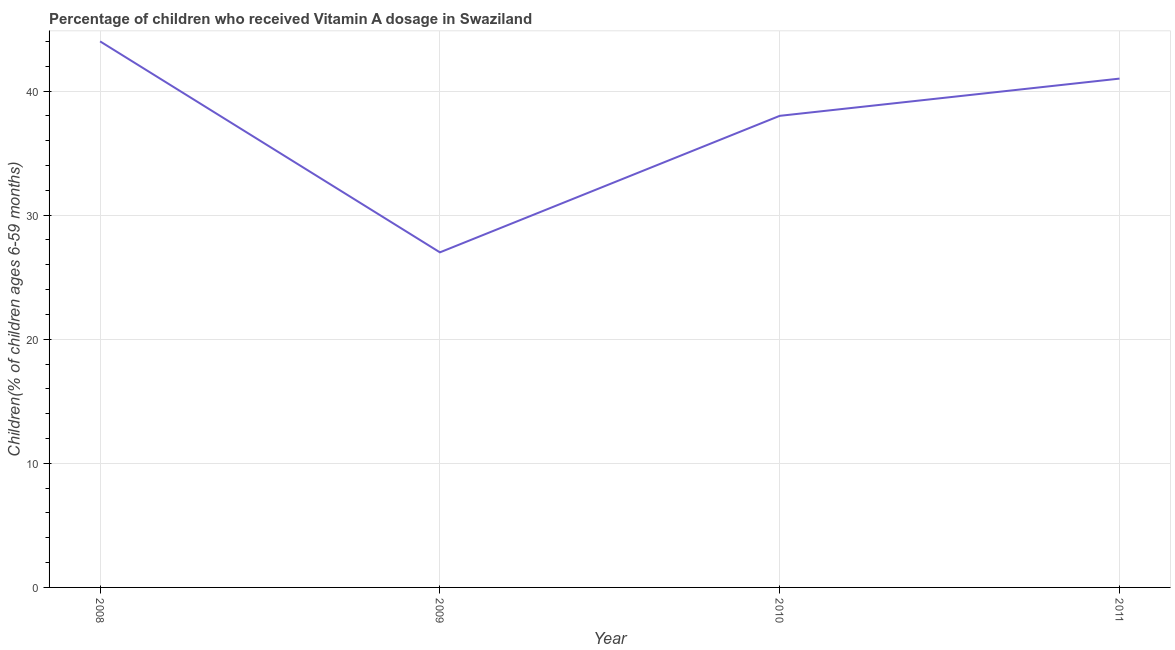What is the vitamin a supplementation coverage rate in 2010?
Offer a terse response. 38. Across all years, what is the maximum vitamin a supplementation coverage rate?
Make the answer very short. 44. Across all years, what is the minimum vitamin a supplementation coverage rate?
Offer a terse response. 27. In which year was the vitamin a supplementation coverage rate maximum?
Ensure brevity in your answer.  2008. What is the sum of the vitamin a supplementation coverage rate?
Make the answer very short. 150. What is the difference between the vitamin a supplementation coverage rate in 2010 and 2011?
Provide a succinct answer. -3. What is the average vitamin a supplementation coverage rate per year?
Your answer should be compact. 37.5. What is the median vitamin a supplementation coverage rate?
Give a very brief answer. 39.5. In how many years, is the vitamin a supplementation coverage rate greater than 40 %?
Give a very brief answer. 2. What is the ratio of the vitamin a supplementation coverage rate in 2010 to that in 2011?
Your answer should be very brief. 0.93. Is the vitamin a supplementation coverage rate in 2008 less than that in 2010?
Give a very brief answer. No. What is the difference between the highest and the lowest vitamin a supplementation coverage rate?
Provide a succinct answer. 17. In how many years, is the vitamin a supplementation coverage rate greater than the average vitamin a supplementation coverage rate taken over all years?
Keep it short and to the point. 3. Does the vitamin a supplementation coverage rate monotonically increase over the years?
Your answer should be compact. No. How many lines are there?
Offer a terse response. 1. How many years are there in the graph?
Your answer should be compact. 4. Are the values on the major ticks of Y-axis written in scientific E-notation?
Make the answer very short. No. Does the graph contain grids?
Keep it short and to the point. Yes. What is the title of the graph?
Provide a short and direct response. Percentage of children who received Vitamin A dosage in Swaziland. What is the label or title of the Y-axis?
Ensure brevity in your answer.  Children(% of children ages 6-59 months). What is the Children(% of children ages 6-59 months) in 2008?
Your answer should be compact. 44. What is the Children(% of children ages 6-59 months) in 2010?
Provide a succinct answer. 38. What is the Children(% of children ages 6-59 months) of 2011?
Ensure brevity in your answer.  41. What is the difference between the Children(% of children ages 6-59 months) in 2008 and 2009?
Ensure brevity in your answer.  17. What is the difference between the Children(% of children ages 6-59 months) in 2008 and 2010?
Provide a succinct answer. 6. What is the difference between the Children(% of children ages 6-59 months) in 2010 and 2011?
Give a very brief answer. -3. What is the ratio of the Children(% of children ages 6-59 months) in 2008 to that in 2009?
Ensure brevity in your answer.  1.63. What is the ratio of the Children(% of children ages 6-59 months) in 2008 to that in 2010?
Ensure brevity in your answer.  1.16. What is the ratio of the Children(% of children ages 6-59 months) in 2008 to that in 2011?
Offer a very short reply. 1.07. What is the ratio of the Children(% of children ages 6-59 months) in 2009 to that in 2010?
Your response must be concise. 0.71. What is the ratio of the Children(% of children ages 6-59 months) in 2009 to that in 2011?
Ensure brevity in your answer.  0.66. What is the ratio of the Children(% of children ages 6-59 months) in 2010 to that in 2011?
Your answer should be very brief. 0.93. 